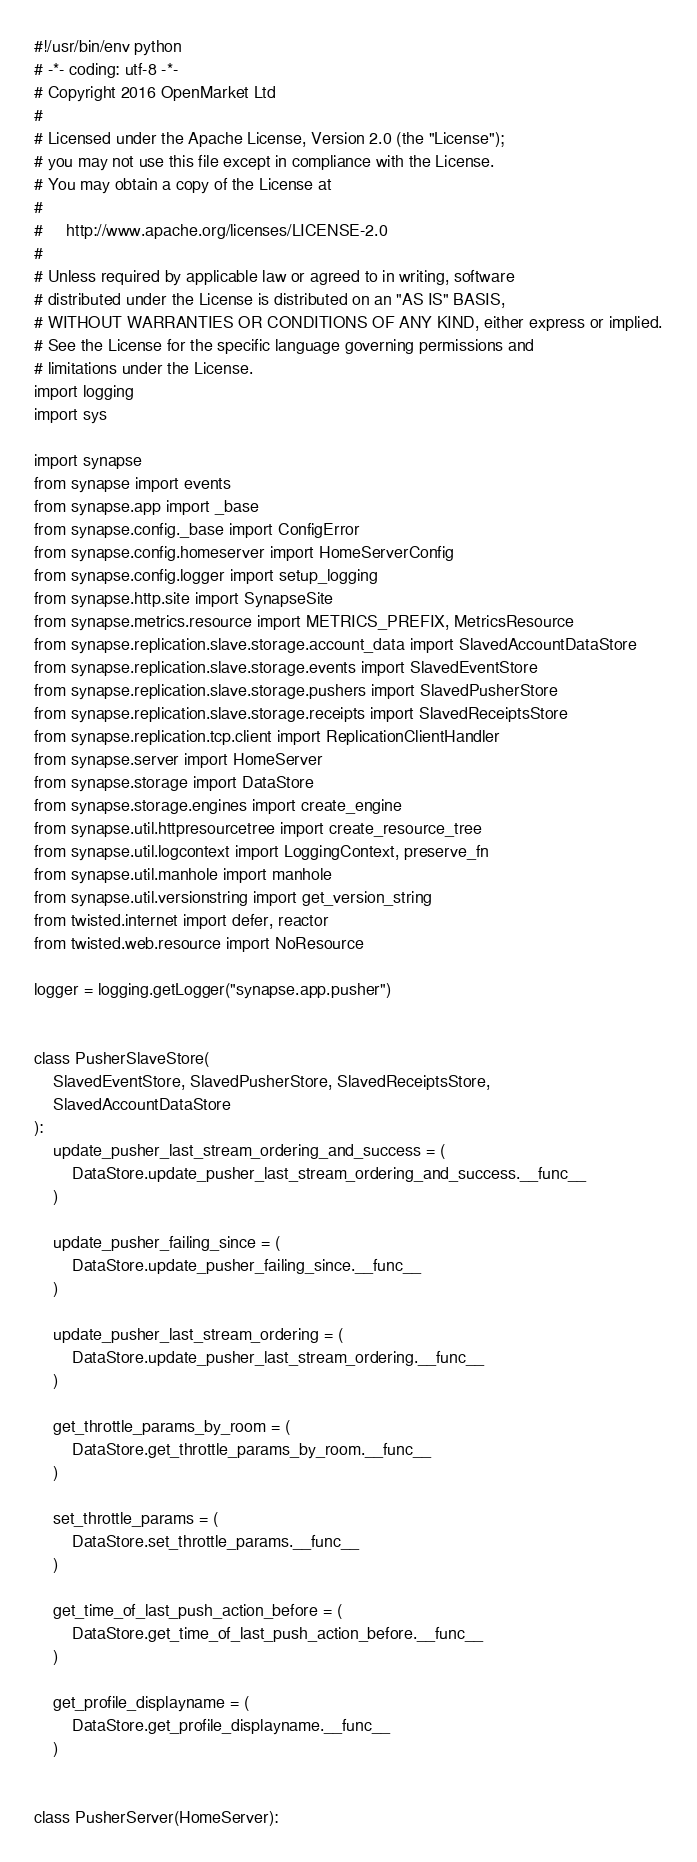Convert code to text. <code><loc_0><loc_0><loc_500><loc_500><_Python_>#!/usr/bin/env python
# -*- coding: utf-8 -*-
# Copyright 2016 OpenMarket Ltd
#
# Licensed under the Apache License, Version 2.0 (the "License");
# you may not use this file except in compliance with the License.
# You may obtain a copy of the License at
#
#     http://www.apache.org/licenses/LICENSE-2.0
#
# Unless required by applicable law or agreed to in writing, software
# distributed under the License is distributed on an "AS IS" BASIS,
# WITHOUT WARRANTIES OR CONDITIONS OF ANY KIND, either express or implied.
# See the License for the specific language governing permissions and
# limitations under the License.
import logging
import sys

import synapse
from synapse import events
from synapse.app import _base
from synapse.config._base import ConfigError
from synapse.config.homeserver import HomeServerConfig
from synapse.config.logger import setup_logging
from synapse.http.site import SynapseSite
from synapse.metrics.resource import METRICS_PREFIX, MetricsResource
from synapse.replication.slave.storage.account_data import SlavedAccountDataStore
from synapse.replication.slave.storage.events import SlavedEventStore
from synapse.replication.slave.storage.pushers import SlavedPusherStore
from synapse.replication.slave.storage.receipts import SlavedReceiptsStore
from synapse.replication.tcp.client import ReplicationClientHandler
from synapse.server import HomeServer
from synapse.storage import DataStore
from synapse.storage.engines import create_engine
from synapse.util.httpresourcetree import create_resource_tree
from synapse.util.logcontext import LoggingContext, preserve_fn
from synapse.util.manhole import manhole
from synapse.util.versionstring import get_version_string
from twisted.internet import defer, reactor
from twisted.web.resource import NoResource

logger = logging.getLogger("synapse.app.pusher")


class PusherSlaveStore(
    SlavedEventStore, SlavedPusherStore, SlavedReceiptsStore,
    SlavedAccountDataStore
):
    update_pusher_last_stream_ordering_and_success = (
        DataStore.update_pusher_last_stream_ordering_and_success.__func__
    )

    update_pusher_failing_since = (
        DataStore.update_pusher_failing_since.__func__
    )

    update_pusher_last_stream_ordering = (
        DataStore.update_pusher_last_stream_ordering.__func__
    )

    get_throttle_params_by_room = (
        DataStore.get_throttle_params_by_room.__func__
    )

    set_throttle_params = (
        DataStore.set_throttle_params.__func__
    )

    get_time_of_last_push_action_before = (
        DataStore.get_time_of_last_push_action_before.__func__
    )

    get_profile_displayname = (
        DataStore.get_profile_displayname.__func__
    )


class PusherServer(HomeServer):</code> 